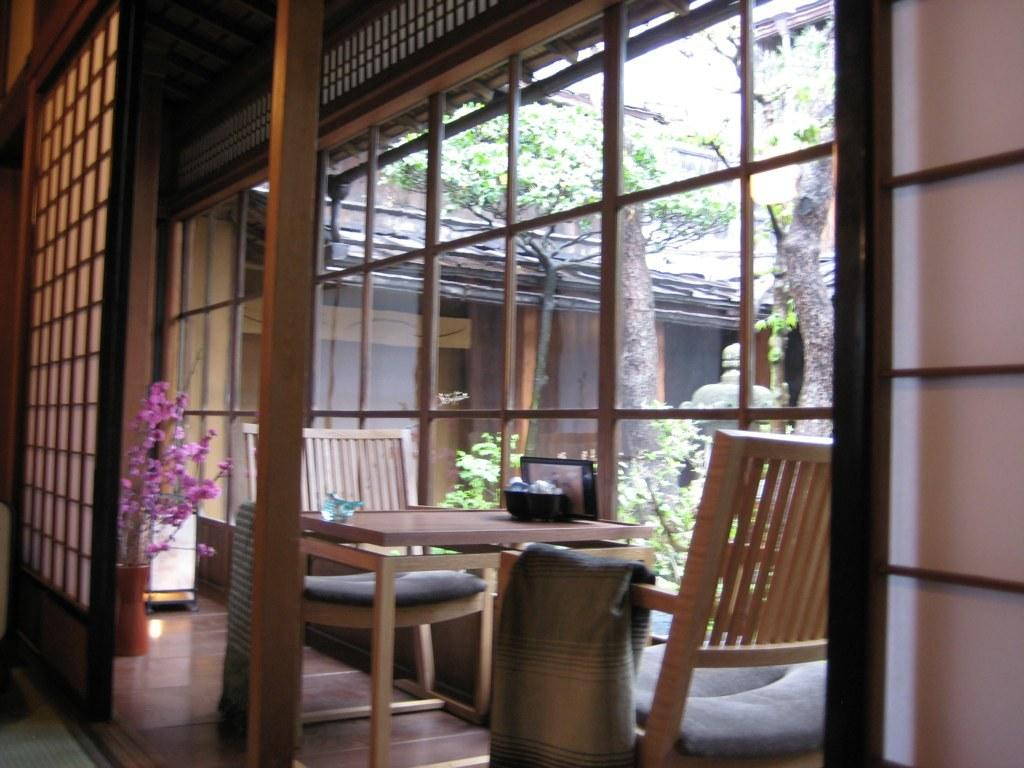What type of furniture is present in the image? There is a wooden table and wooden chairs in the image. What can be found on the table? There is a flower vase on the table in the image. What architectural elements are visible in the image? There are pillars in the image. What type of vegetation is present in the image? There are trees in the image. What type of structure is visible in the image? There is a wooden house in the image. What type of soda is being served in the wooden house in the image? There is no soda present in the image; it only features a wooden table, wooden chairs, a flower vase, pillars, trees, and a wooden house. What type of wire is used to connect the trees in the image? There is no wire connecting the trees in the image; they are separate entities. 